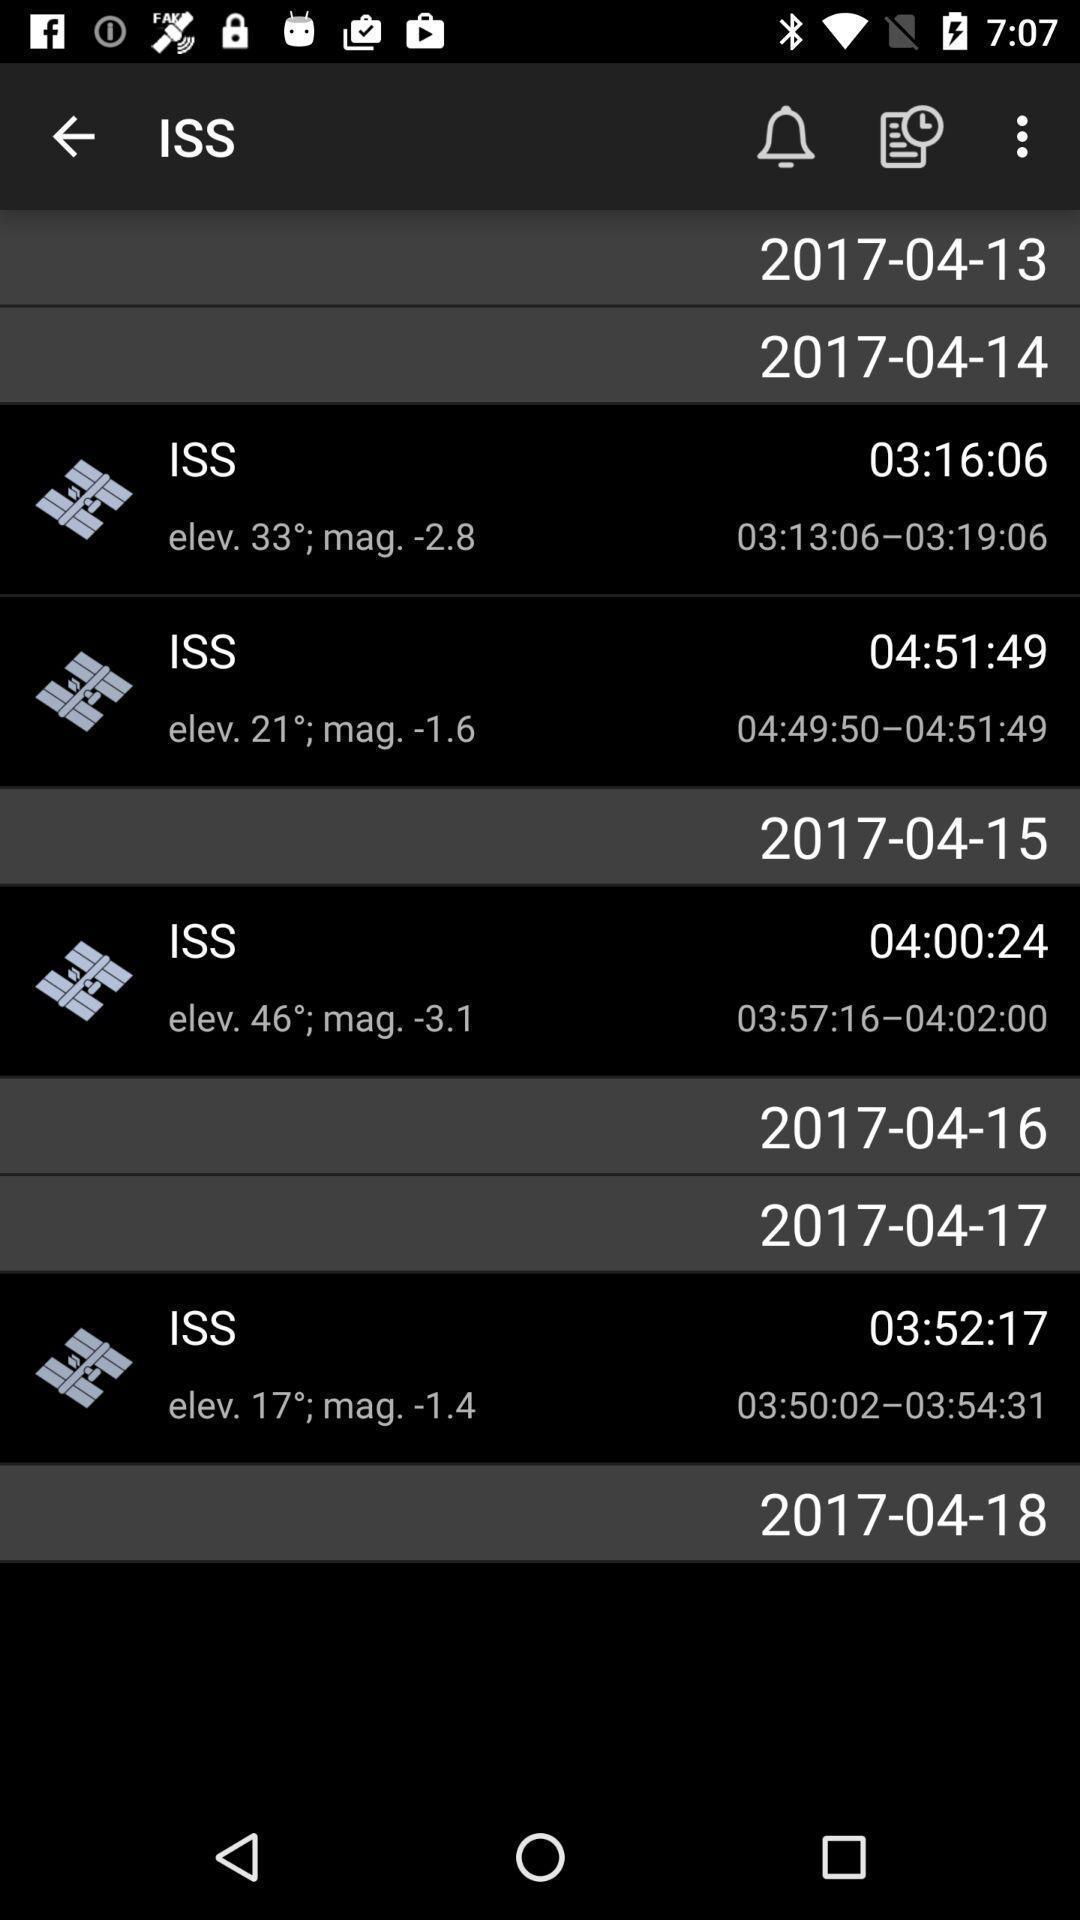What details can you identify in this image? Screen page of an alarm application. 